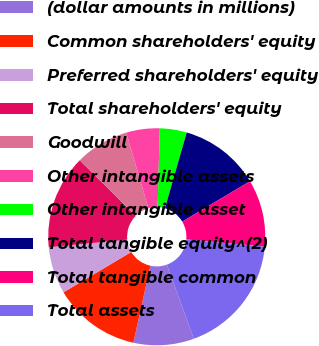<chart> <loc_0><loc_0><loc_500><loc_500><pie_chart><fcel>(dollar amounts in millions)<fcel>Common shareholders' equity<fcel>Preferred shareholders' equity<fcel>Total shareholders' equity<fcel>Goodwill<fcel>Other intangible assets<fcel>Other intangible asset<fcel>Total tangible equity^(2)<fcel>Total tangible common<fcel>Total assets<nl><fcel>9.0%<fcel>13.0%<fcel>7.0%<fcel>14.0%<fcel>8.0%<fcel>5.0%<fcel>4.0%<fcel>12.0%<fcel>10.0%<fcel>18.0%<nl></chart> 